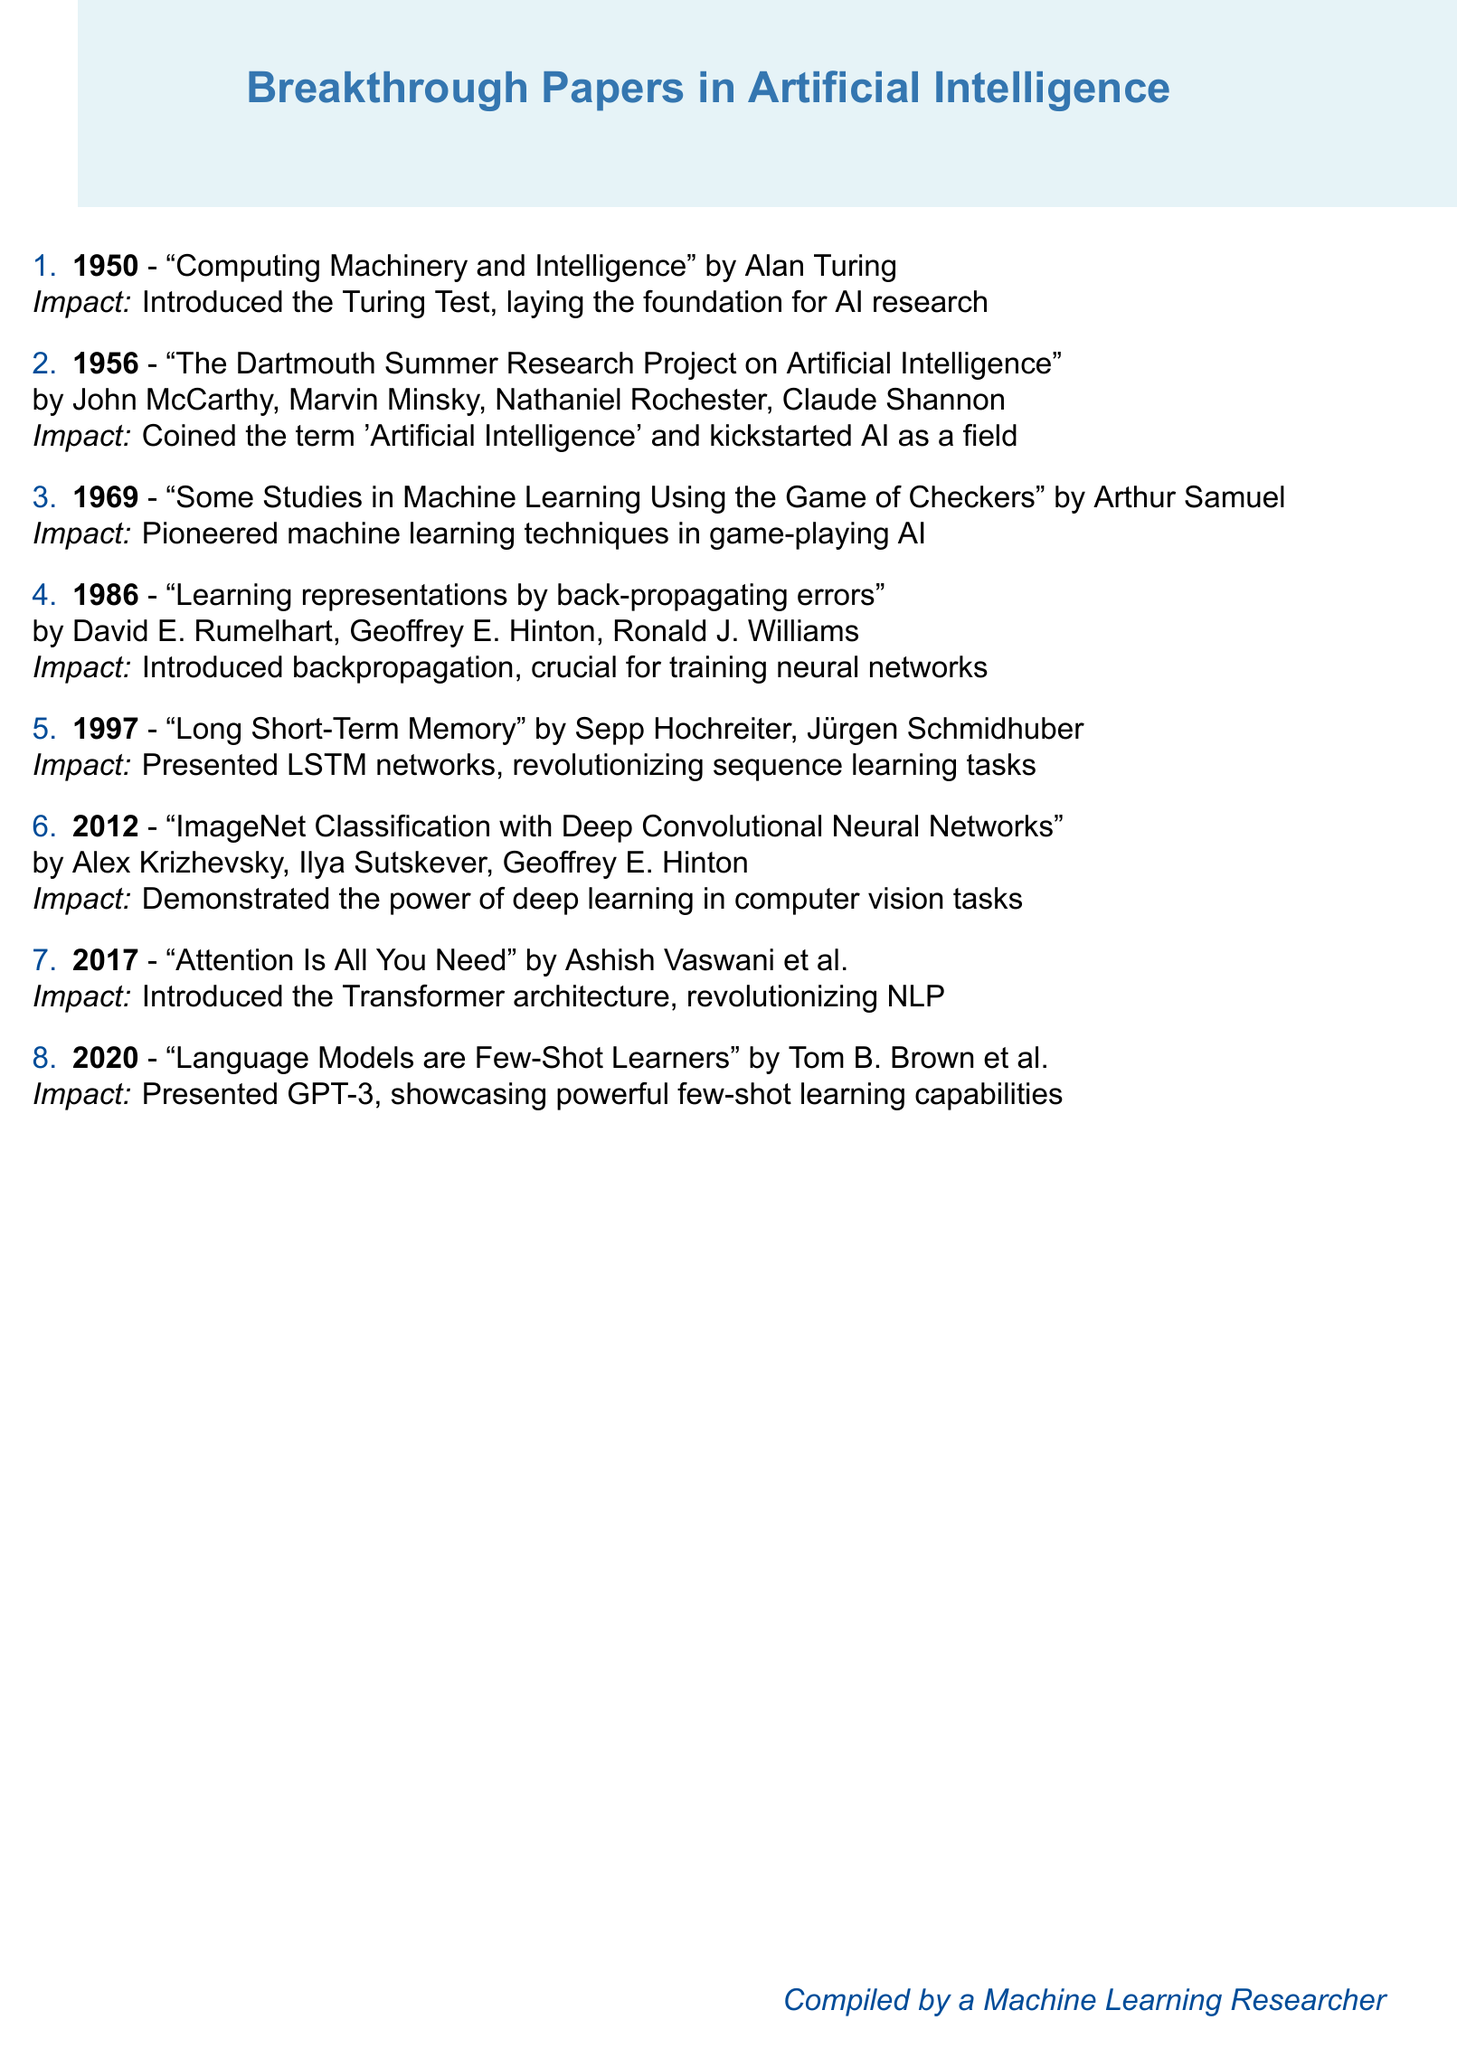What year was "Computing Machinery and Intelligence" published? The document states that it was published in 1950.
Answer: 1950 Who introduced the term 'Artificial Intelligence'? John McCarthy and others coined the term during the Dartmouth Conference in 1956.
Answer: John McCarthy What innovation did Arthur Samuel contribute in 1969? He pioneered machine learning techniques, particularly in game-playing AI.
Answer: Machine learning techniques In which year was backpropagation introduced? The document indicates that the introduction of backpropagation occurred in 1986.
Answer: 1986 What does LSTM stand for? The document mentions LSTM networks, which stands for Long Short-Term Memory.
Answer: Long Short-Term Memory Which paper demonstrated the effectiveness of deep learning in computer vision? The 2012 paper by Alex Krizhevsky and others fulfilled this purpose.
Answer: ImageNet Classification with Deep Convolutional Neural Networks What is the key innovation introduced by the paper published in 2017? The document highlights the introduction of the Transformer architecture in this paper.
Answer: Transformer architecture Which paper is known for showcasing GPT-3's capabilities? The 2020 paper by Tom B. Brown and colleagues discusses GPT-3.
Answer: Language Models are Few-Shot Learners How many authors contributed to the "Attention Is All You Need" paper? The document lists Ashish Vaswani et al., indicating more than one author contributed.
Answer: Multiple authors 